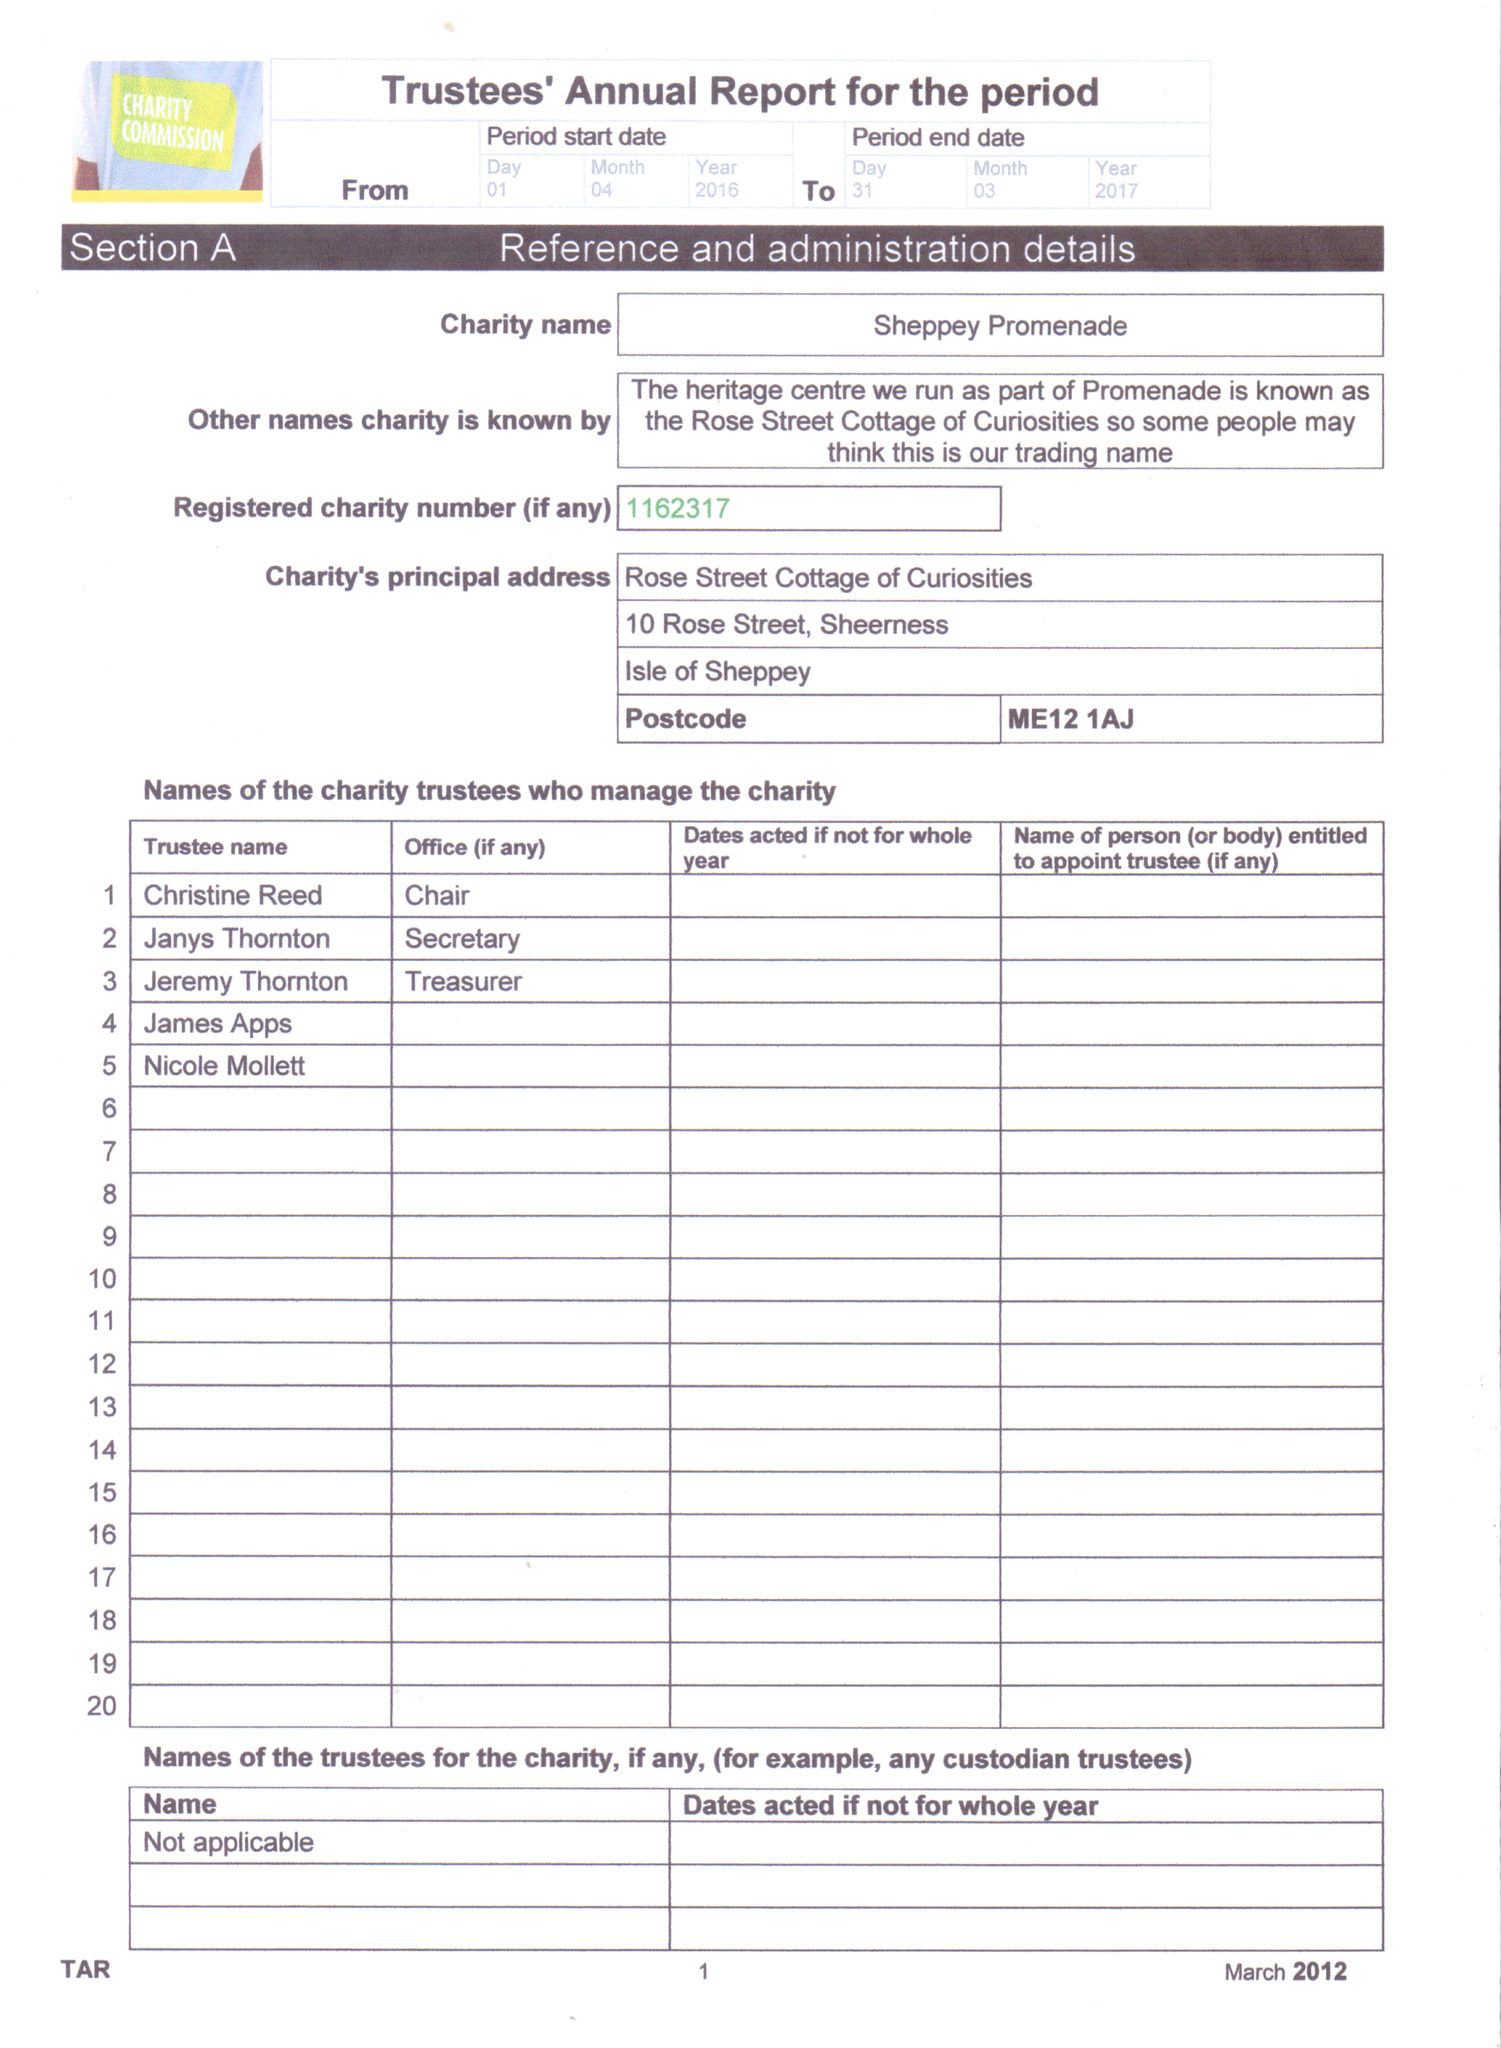What is the value for the income_annually_in_british_pounds?
Answer the question using a single word or phrase. 10594.00 